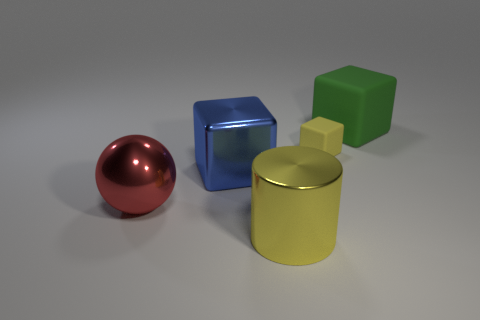Imagine these objects are part of a learning module for children. What kind of exercises could be designed around them? These objects could serve as educational tools in a variety of engaging learning exercises. For instance, children could be asked to identify each shape and color, match the objects to similarly colored items, or arrange them according to size. More advanced exercises might involve discussions about light and shadow, the concepts of reflection and texture, and even basic geometry by calculating the volume of each shape. 